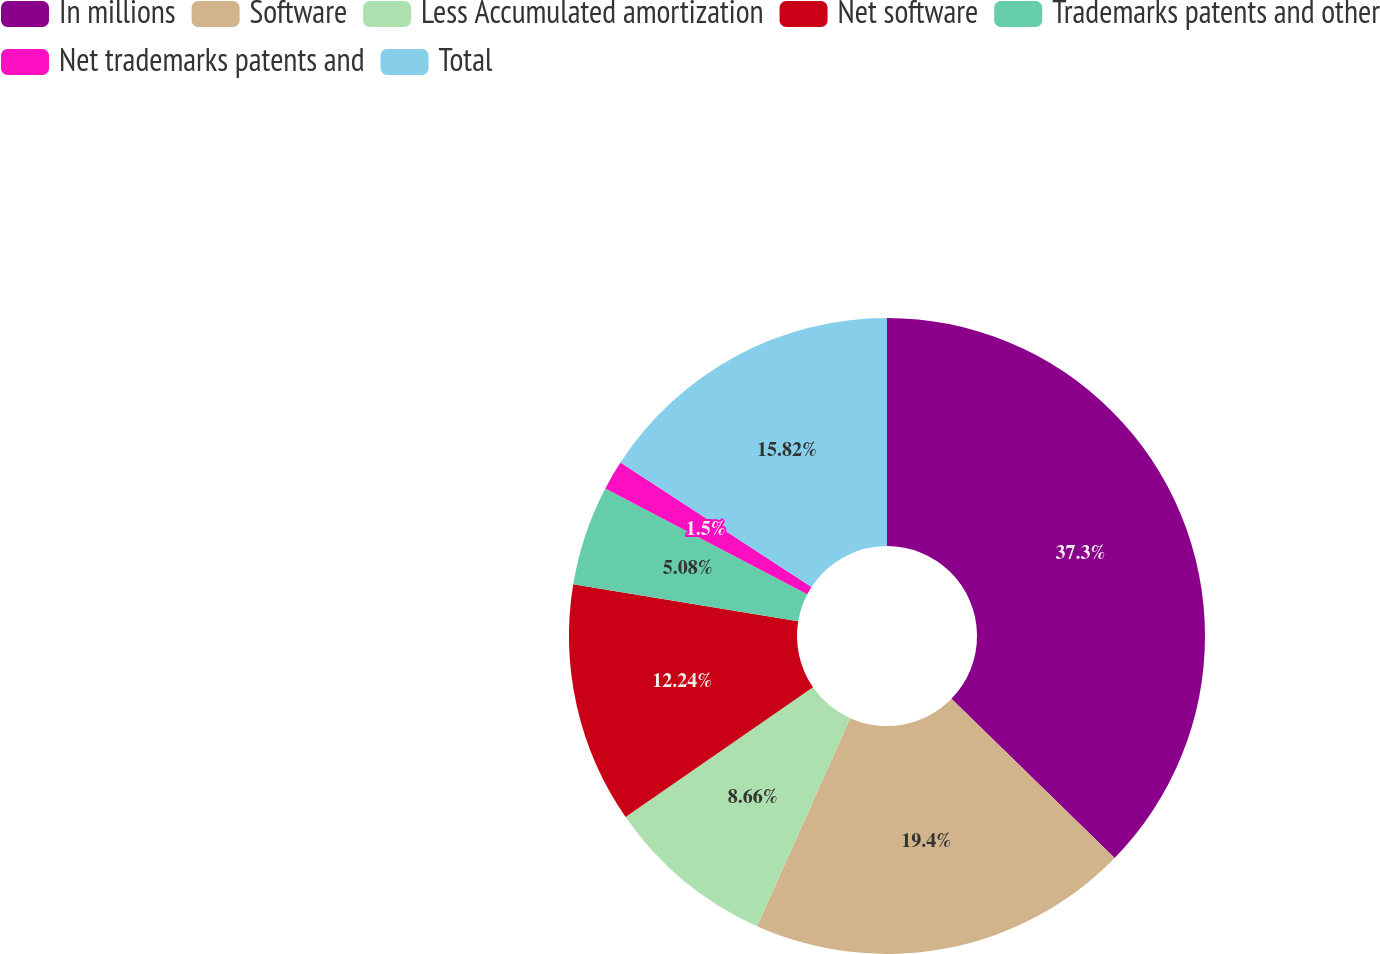<chart> <loc_0><loc_0><loc_500><loc_500><pie_chart><fcel>In millions<fcel>Software<fcel>Less Accumulated amortization<fcel>Net software<fcel>Trademarks patents and other<fcel>Net trademarks patents and<fcel>Total<nl><fcel>37.3%<fcel>19.4%<fcel>8.66%<fcel>12.24%<fcel>5.08%<fcel>1.5%<fcel>15.82%<nl></chart> 